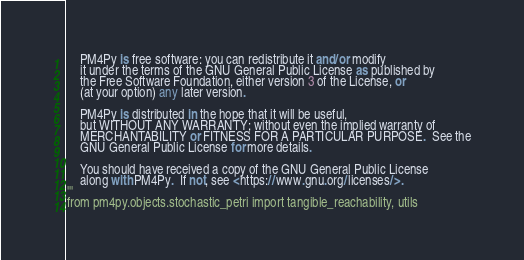<code> <loc_0><loc_0><loc_500><loc_500><_Python_>    PM4Py is free software: you can redistribute it and/or modify
    it under the terms of the GNU General Public License as published by
    the Free Software Foundation, either version 3 of the License, or
    (at your option) any later version.

    PM4Py is distributed in the hope that it will be useful,
    but WITHOUT ANY WARRANTY; without even the implied warranty of
    MERCHANTABILITY or FITNESS FOR A PARTICULAR PURPOSE.  See the
    GNU General Public License for more details.

    You should have received a copy of the GNU General Public License
    along with PM4Py.  If not, see <https://www.gnu.org/licenses/>.
'''
from pm4py.objects.stochastic_petri import tangible_reachability, utils
</code> 